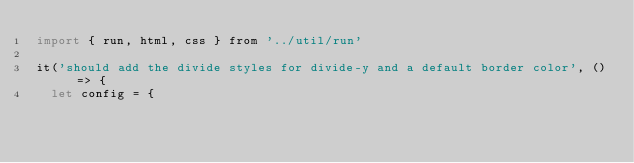<code> <loc_0><loc_0><loc_500><loc_500><_JavaScript_>import { run, html, css } from '../util/run'

it('should add the divide styles for divide-y and a default border color', () => {
  let config = {</code> 